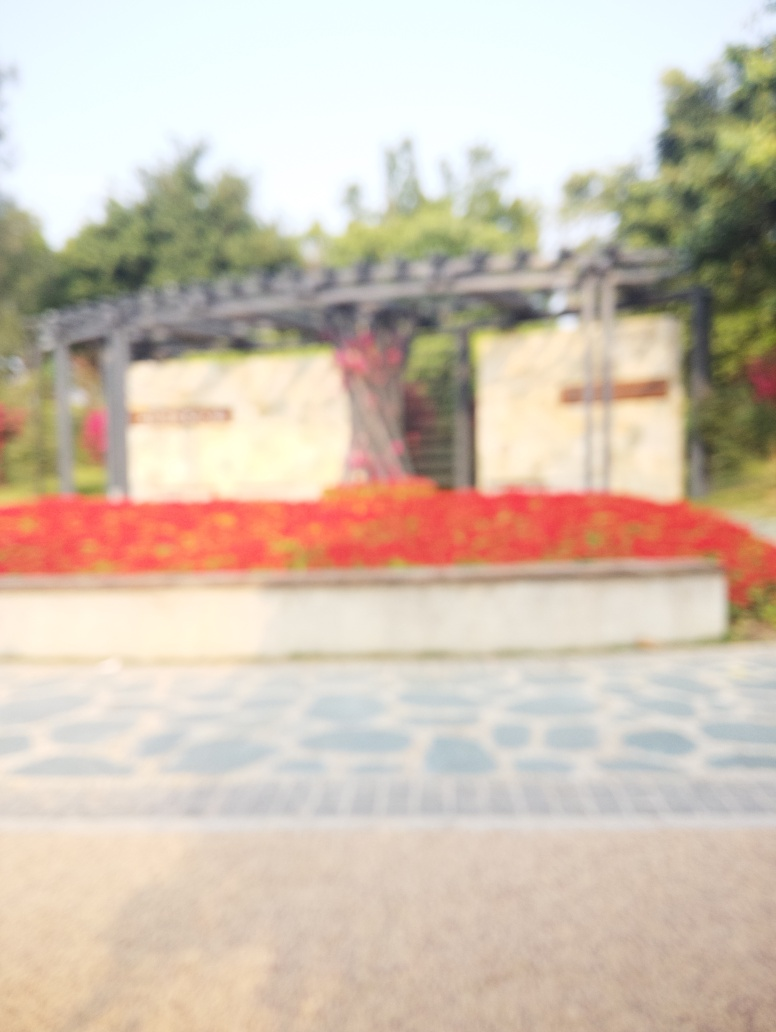Can you tell if this is a private or public space? The image suggests that this could be a public space, perhaps the entrance to a park or communal garden, given the open walkway and the informal arrangement of the red flowers, which are typical of spaces designed for public enjoyment. 